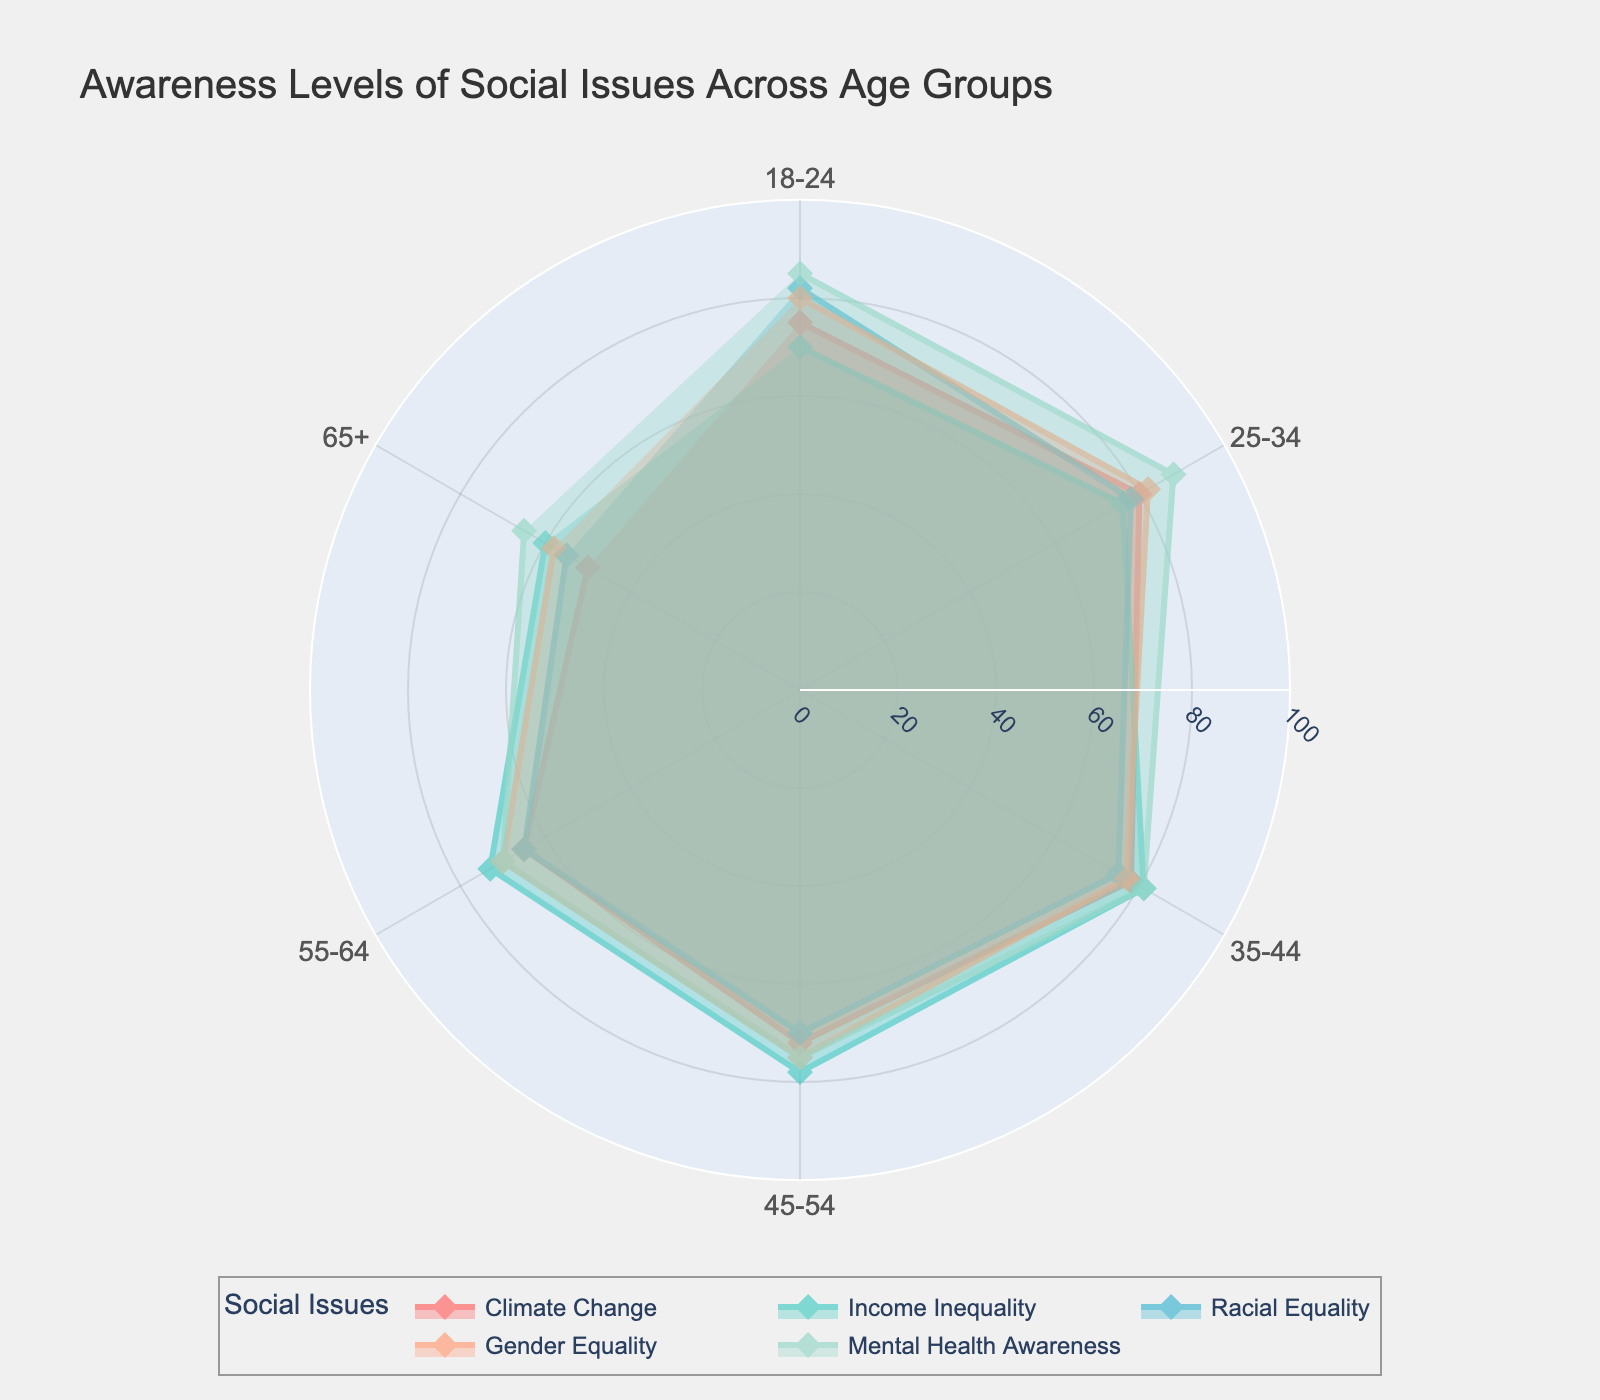What is the title of the polar chart? The title is usually located at the top of the chart in a prominent font size. By reading the title, we can determine that it is "Awareness Levels of Social Issues Across Age Groups".
Answer: Awareness Levels of Social Issues Across Age Groups Which social issue has the highest awareness level for the 18-24 age group? To find this, look at the data points corresponding to the 18-24 age group. The highest value is for Mental Health Awareness, at 85.
Answer: Mental Health Awareness How does awareness of Climate Change compare between the 18-24 and 65+ age groups? To compare awareness, look at the values for Climate Change for both age groups (75 for 18-24 and 50 for 65+). The younger age group has a higher awareness level.
Answer: The 18-24 group has a higher awareness level than the 65+ group What is the average awareness level of Gender Equality across all age groups? Calculate the average by summing the awareness levels for Gender Equality across all age groups (80 + 82 + 77 + 75 + 70 + 58 = 442) and divide by the number of age groups (6).
Answer: 73.67 Which age group has the lowest awareness level for Income Inequality? By looking at the awareness levels for different age groups under Income Inequality, the 65+ group has the lowest level at 60.
Answer: 65+ Compare the awareness levels of Racial Equality and Mental Health Awareness for the 45-54 age group. Identify the values for these issues for the 45-54 age group, which are 70 for Racial Equality and 75 for Mental Health Awareness. Mental Health Awareness is higher.
Answer: Mental Health Awareness is higher Which social issue has the most uniform awareness across all age groups? Uniformity can be checked by looking at the range of awareness levels. Climate Change varies from 75 to 50, Gender Equality from 80 to 58, Income Inequality from 70 to 60, Racial Equality from 82 to 55, and Mental Health Awareness from 85 to 65. Gender Equality has the smallest range (24).
Answer: Gender Equality If you combine the awareness levels of Climate Change and Income Inequality for the 35-44 age group, what is the total? Sum the awareness levels of Climate Change (78) and Income Inequality (81) for the 35-44 age group.
Answer: 159 What is the overall trend in awareness levels as age increases for Racial Equality? Examine the data points for Racial Equality from youngest to oldest age group: 82, 78, 75, 70, 65, 55 - awareness decreases with age.
Answer: Decreasing 